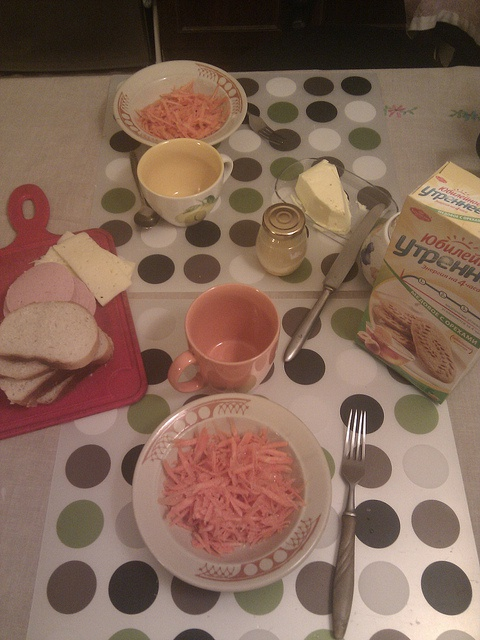Describe the objects in this image and their specific colors. I can see dining table in gray, tan, black, and darkgray tones, bowl in black, brown, gray, and darkgray tones, carrot in black, brown, and salmon tones, cup in black, brown, and salmon tones, and bowl in black, brown, and tan tones in this image. 